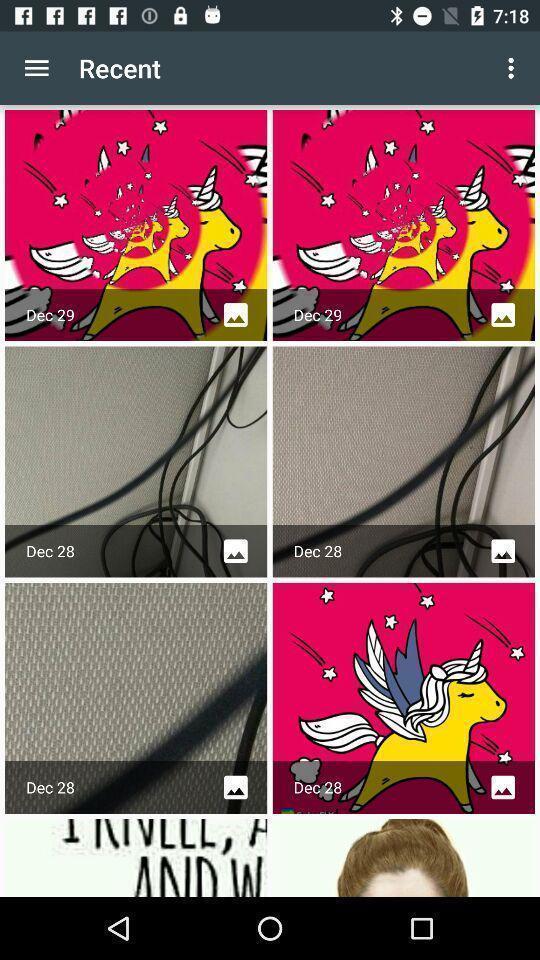Give me a narrative description of this picture. Screen displaying multiple images in a gallery. 